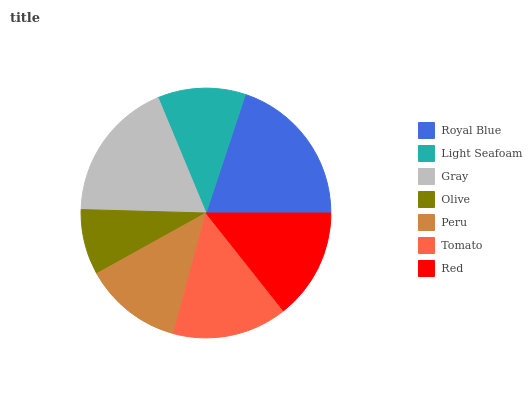Is Olive the minimum?
Answer yes or no. Yes. Is Royal Blue the maximum?
Answer yes or no. Yes. Is Light Seafoam the minimum?
Answer yes or no. No. Is Light Seafoam the maximum?
Answer yes or no. No. Is Royal Blue greater than Light Seafoam?
Answer yes or no. Yes. Is Light Seafoam less than Royal Blue?
Answer yes or no. Yes. Is Light Seafoam greater than Royal Blue?
Answer yes or no. No. Is Royal Blue less than Light Seafoam?
Answer yes or no. No. Is Red the high median?
Answer yes or no. Yes. Is Red the low median?
Answer yes or no. Yes. Is Tomato the high median?
Answer yes or no. No. Is Tomato the low median?
Answer yes or no. No. 